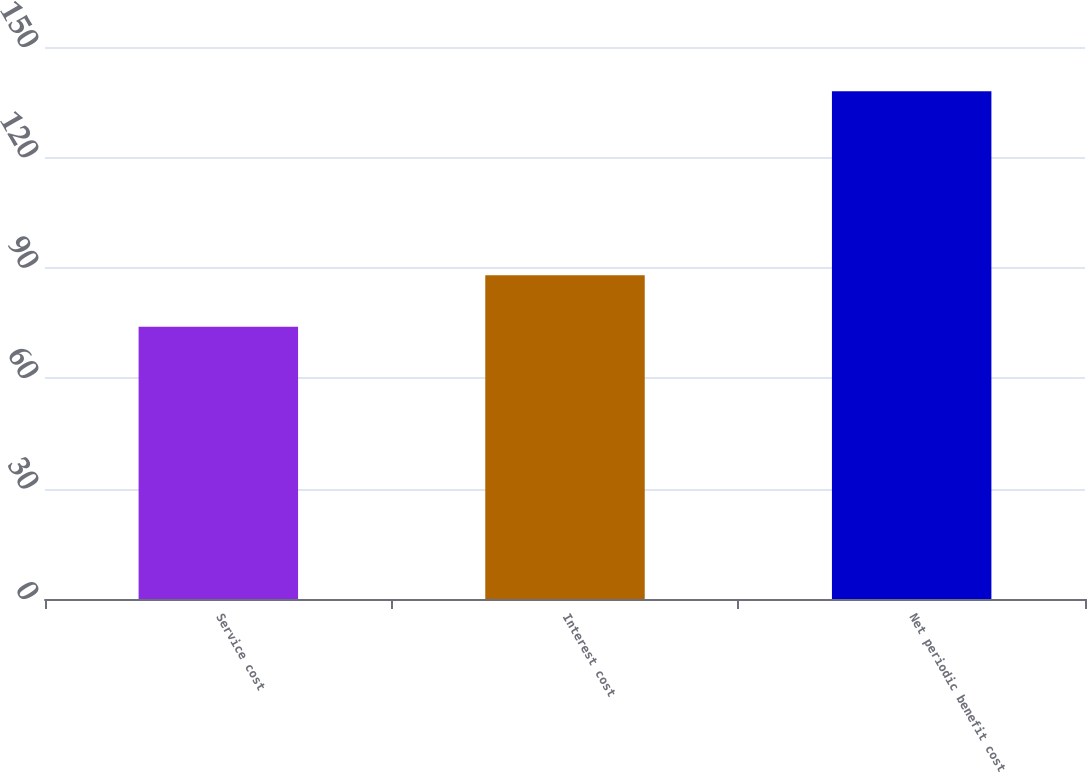Convert chart. <chart><loc_0><loc_0><loc_500><loc_500><bar_chart><fcel>Service cost<fcel>Interest cost<fcel>Net periodic benefit cost<nl><fcel>74<fcel>88<fcel>138<nl></chart> 